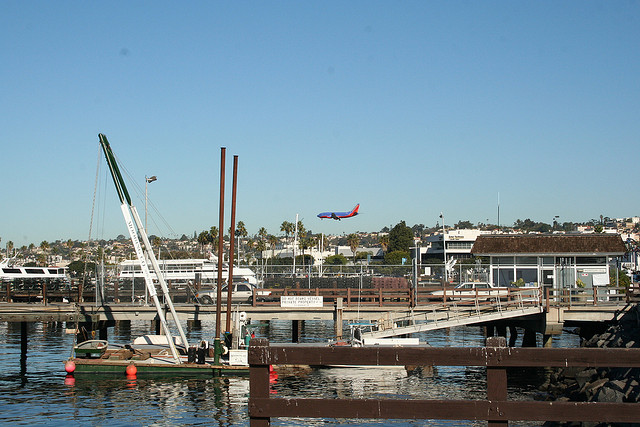Is there an environmental concern that can be discussed based on this image? Certainly, marinas like the one depicted can impact the local marine ecosystem, often concerning water quality due to potential oil spills, fuel leaks from boats, and contamination from runoff. Sustainable practices and careful management are essential to preserve the health of the marine environment and the species that inhabit it. 